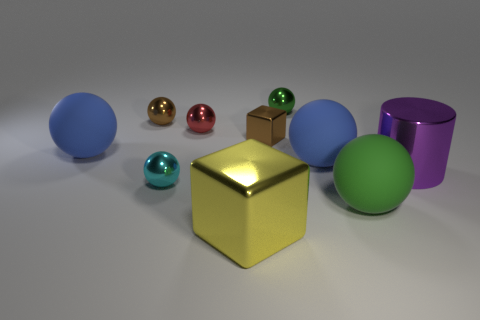What is the arrangement of the objects on the surface? The objects appear randomly scattered, with no clear pattern. The yellow cube is somewhat central, with the green sphere, the blue sphere, and the metallic cylinder resting towards one side, and the red, gold, and turquoise spheres lying closer to the other side. 